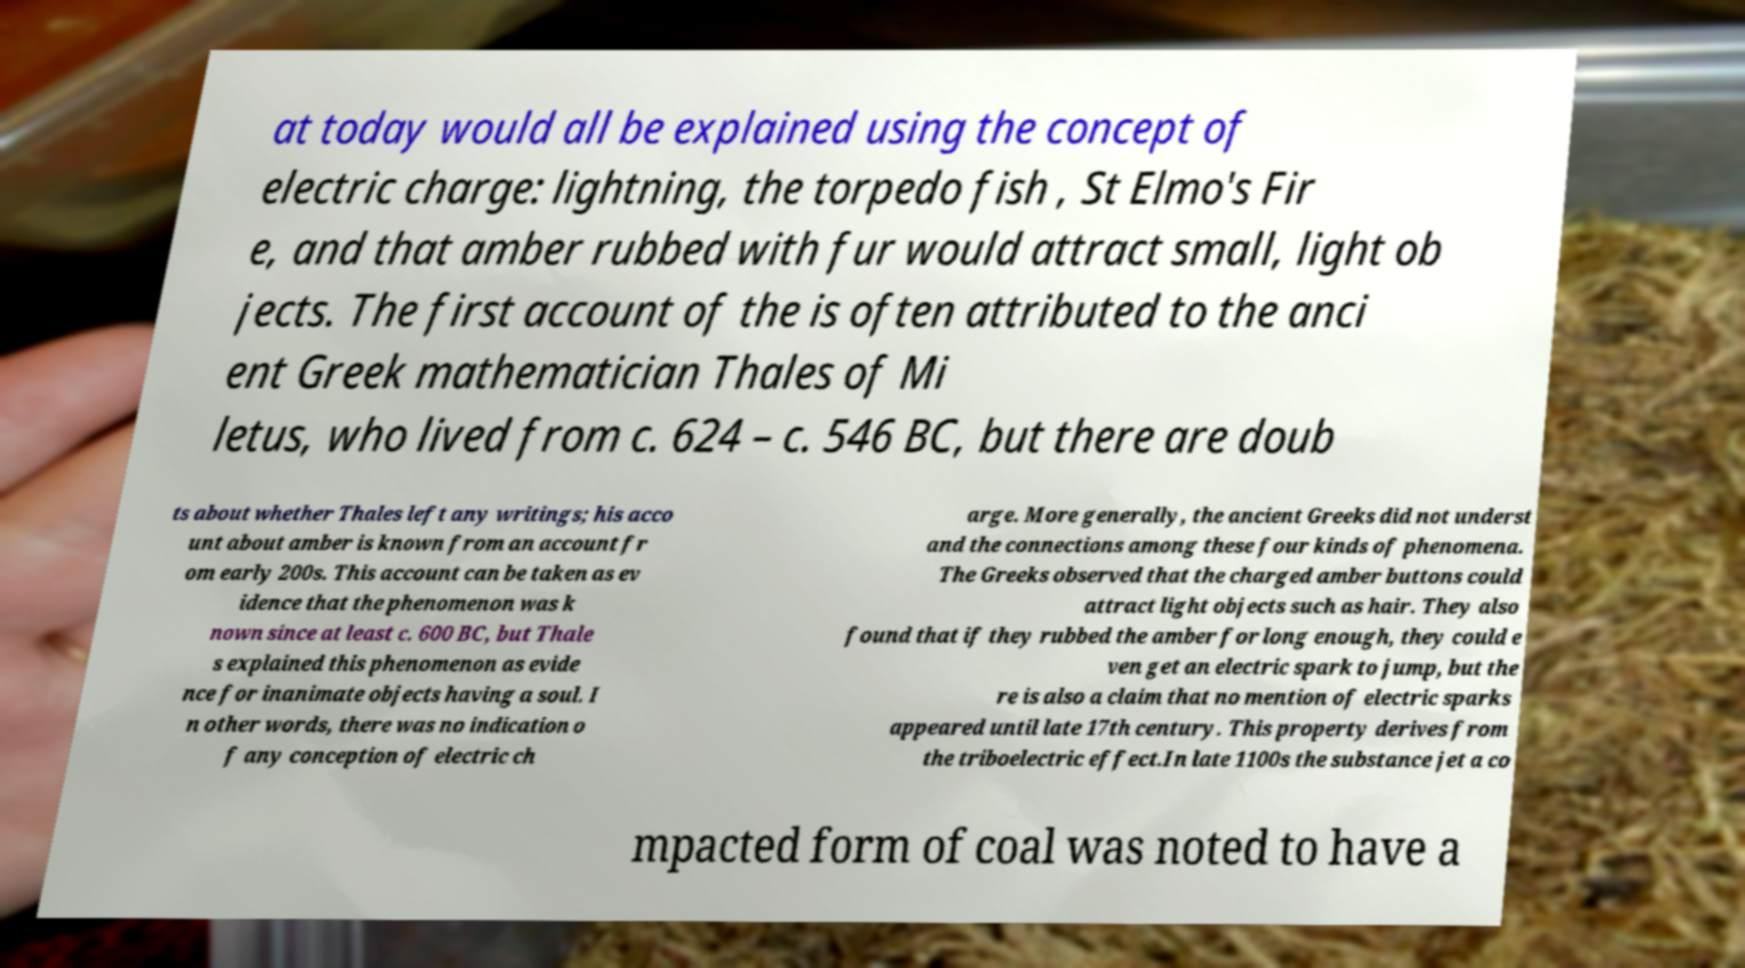I need the written content from this picture converted into text. Can you do that? at today would all be explained using the concept of electric charge: lightning, the torpedo fish , St Elmo's Fir e, and that amber rubbed with fur would attract small, light ob jects. The first account of the is often attributed to the anci ent Greek mathematician Thales of Mi letus, who lived from c. 624 – c. 546 BC, but there are doub ts about whether Thales left any writings; his acco unt about amber is known from an account fr om early 200s. This account can be taken as ev idence that the phenomenon was k nown since at least c. 600 BC, but Thale s explained this phenomenon as evide nce for inanimate objects having a soul. I n other words, there was no indication o f any conception of electric ch arge. More generally, the ancient Greeks did not underst and the connections among these four kinds of phenomena. The Greeks observed that the charged amber buttons could attract light objects such as hair. They also found that if they rubbed the amber for long enough, they could e ven get an electric spark to jump, but the re is also a claim that no mention of electric sparks appeared until late 17th century. This property derives from the triboelectric effect.In late 1100s the substance jet a co mpacted form of coal was noted to have a 